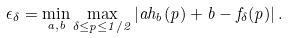Convert formula to latex. <formula><loc_0><loc_0><loc_500><loc_500>\epsilon _ { \delta } = \min _ { a , b } \max _ { \delta \leq p \leq 1 / 2 } \left | a h _ { b } ( p ) + b - f _ { \delta } ( p ) \right | .</formula> 